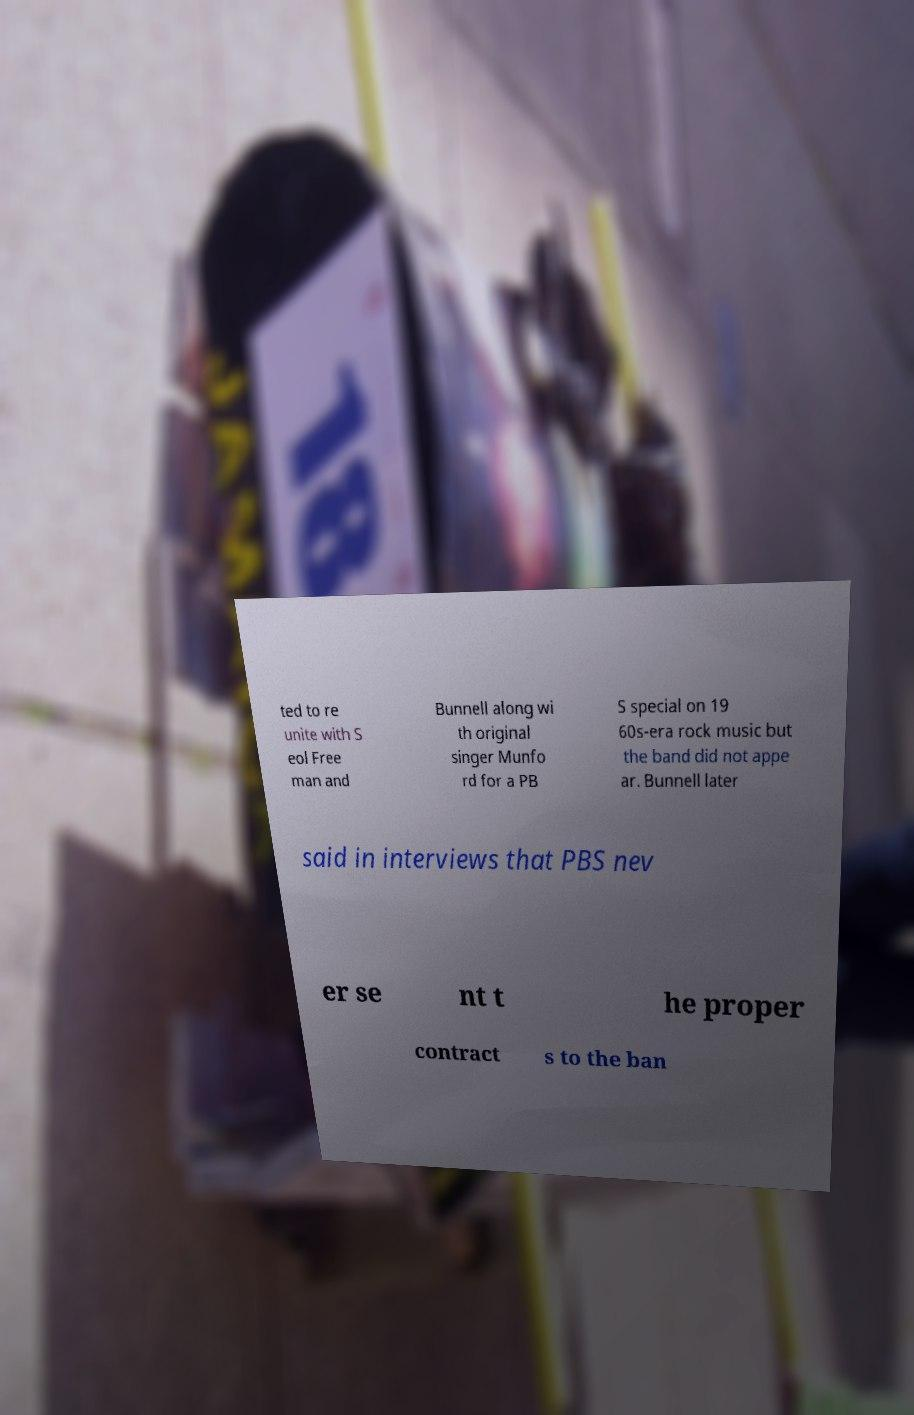Could you assist in decoding the text presented in this image and type it out clearly? ted to re unite with S eol Free man and Bunnell along wi th original singer Munfo rd for a PB S special on 19 60s-era rock music but the band did not appe ar. Bunnell later said in interviews that PBS nev er se nt t he proper contract s to the ban 